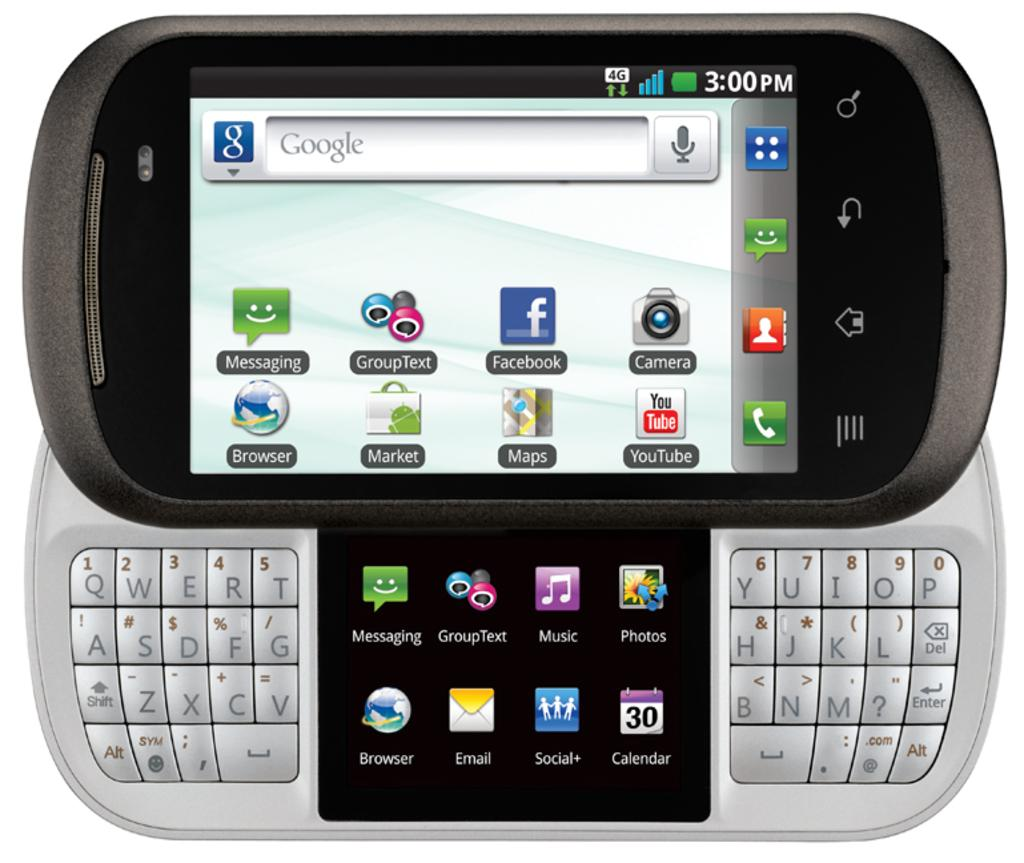<image>
Provide a brief description of the given image. A very old hand held computer has Google as its home page as well as a number of apps. 